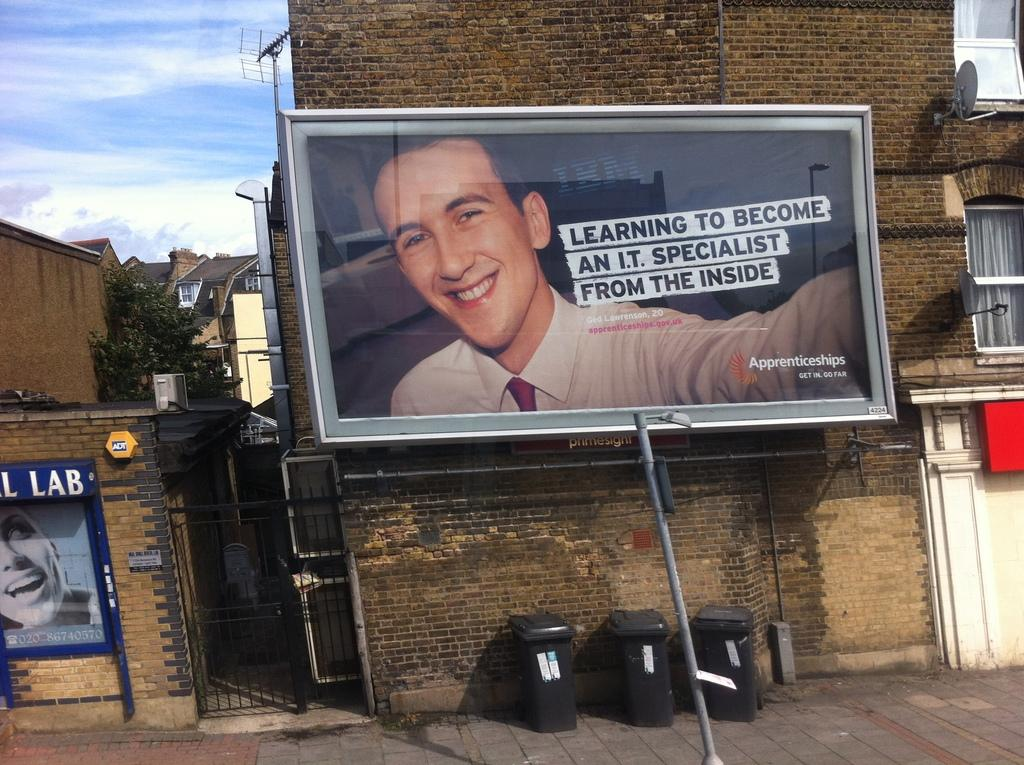<image>
Share a concise interpretation of the image provided. Billboard saying "Learning To Become AN I.T. Specialist From The Inside" in front of some garbage cans. 